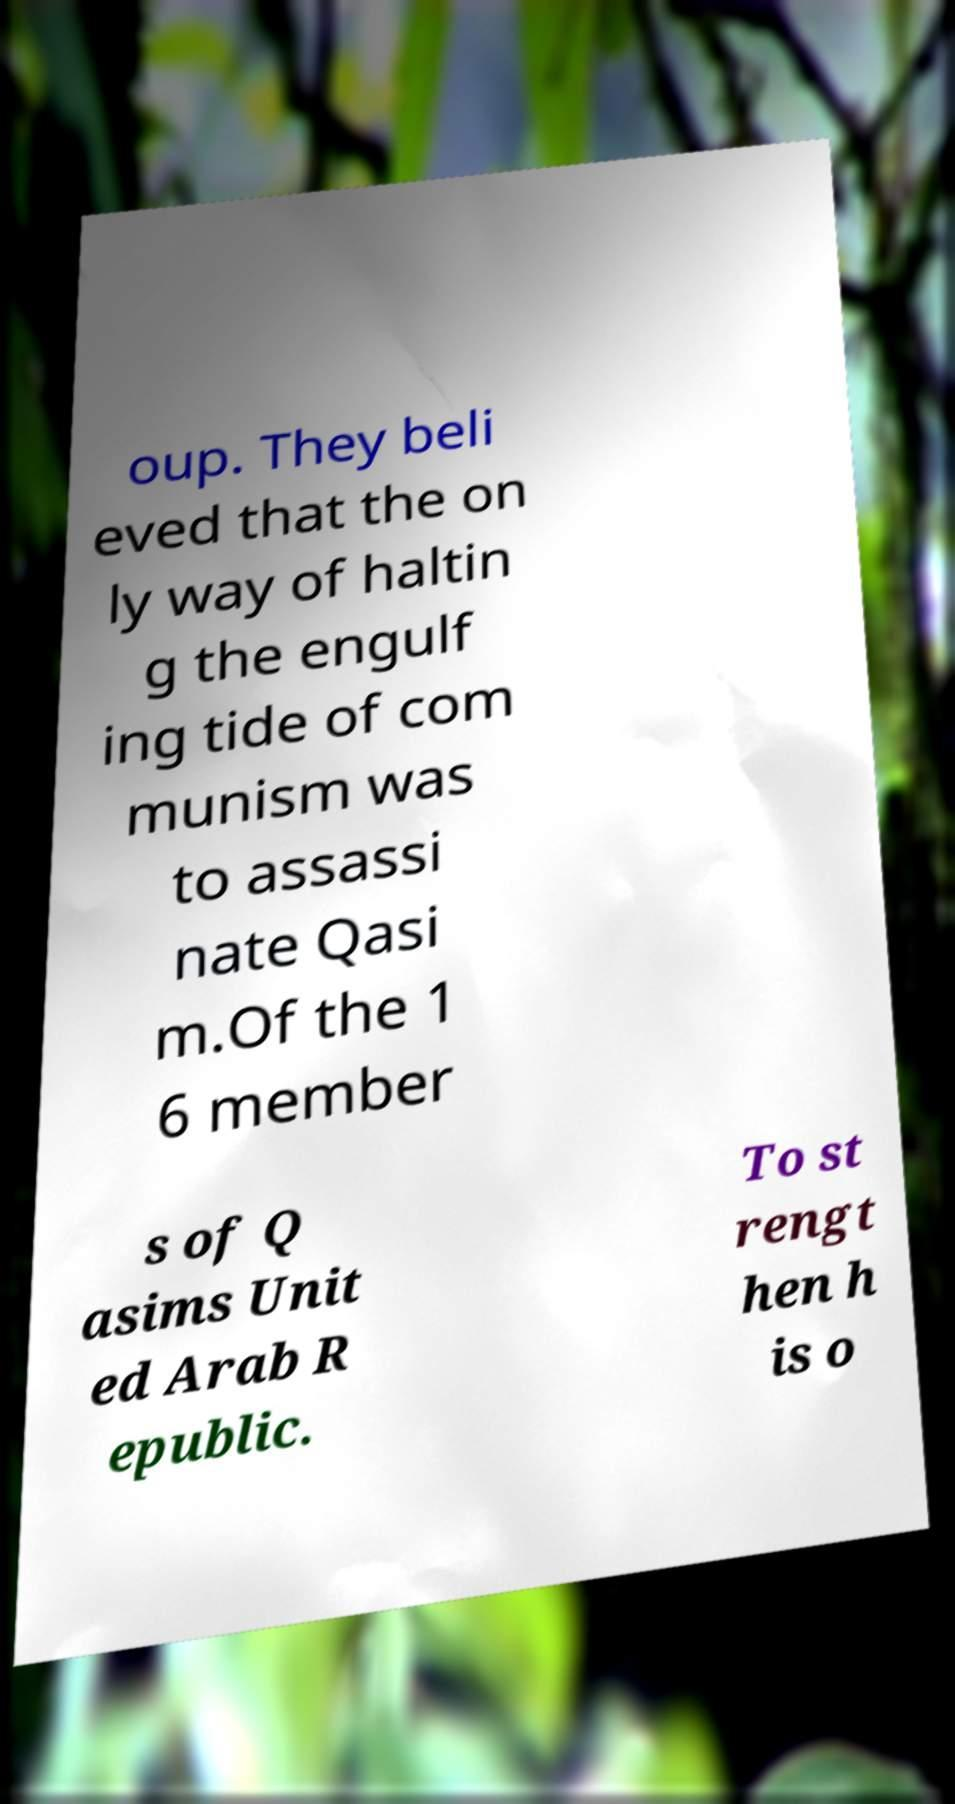Could you assist in decoding the text presented in this image and type it out clearly? oup. They beli eved that the on ly way of haltin g the engulf ing tide of com munism was to assassi nate Qasi m.Of the 1 6 member s of Q asims Unit ed Arab R epublic. To st rengt hen h is o 